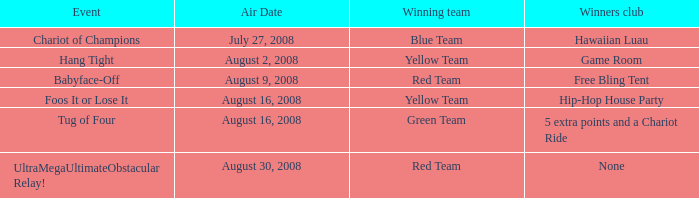How many weeks does the yellow team have a winning streak in the event called "foos it or lose it"? 4.0. 